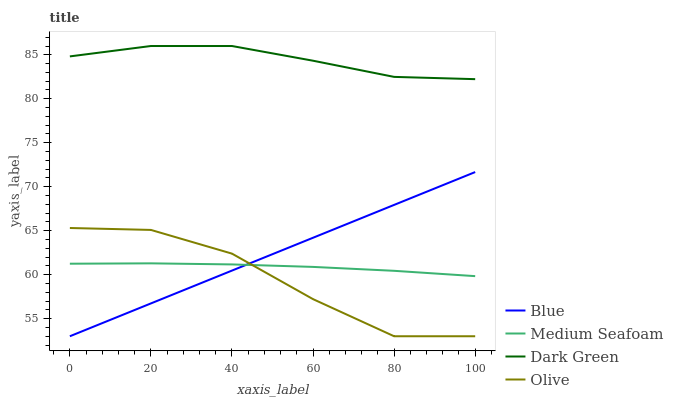Does Olive have the minimum area under the curve?
Answer yes or no. Yes. Does Dark Green have the maximum area under the curve?
Answer yes or no. Yes. Does Medium Seafoam have the minimum area under the curve?
Answer yes or no. No. Does Medium Seafoam have the maximum area under the curve?
Answer yes or no. No. Is Blue the smoothest?
Answer yes or no. Yes. Is Olive the roughest?
Answer yes or no. Yes. Is Medium Seafoam the smoothest?
Answer yes or no. No. Is Medium Seafoam the roughest?
Answer yes or no. No. Does Blue have the lowest value?
Answer yes or no. Yes. Does Medium Seafoam have the lowest value?
Answer yes or no. No. Does Dark Green have the highest value?
Answer yes or no. Yes. Does Olive have the highest value?
Answer yes or no. No. Is Blue less than Dark Green?
Answer yes or no. Yes. Is Dark Green greater than Olive?
Answer yes or no. Yes. Does Medium Seafoam intersect Blue?
Answer yes or no. Yes. Is Medium Seafoam less than Blue?
Answer yes or no. No. Is Medium Seafoam greater than Blue?
Answer yes or no. No. Does Blue intersect Dark Green?
Answer yes or no. No. 